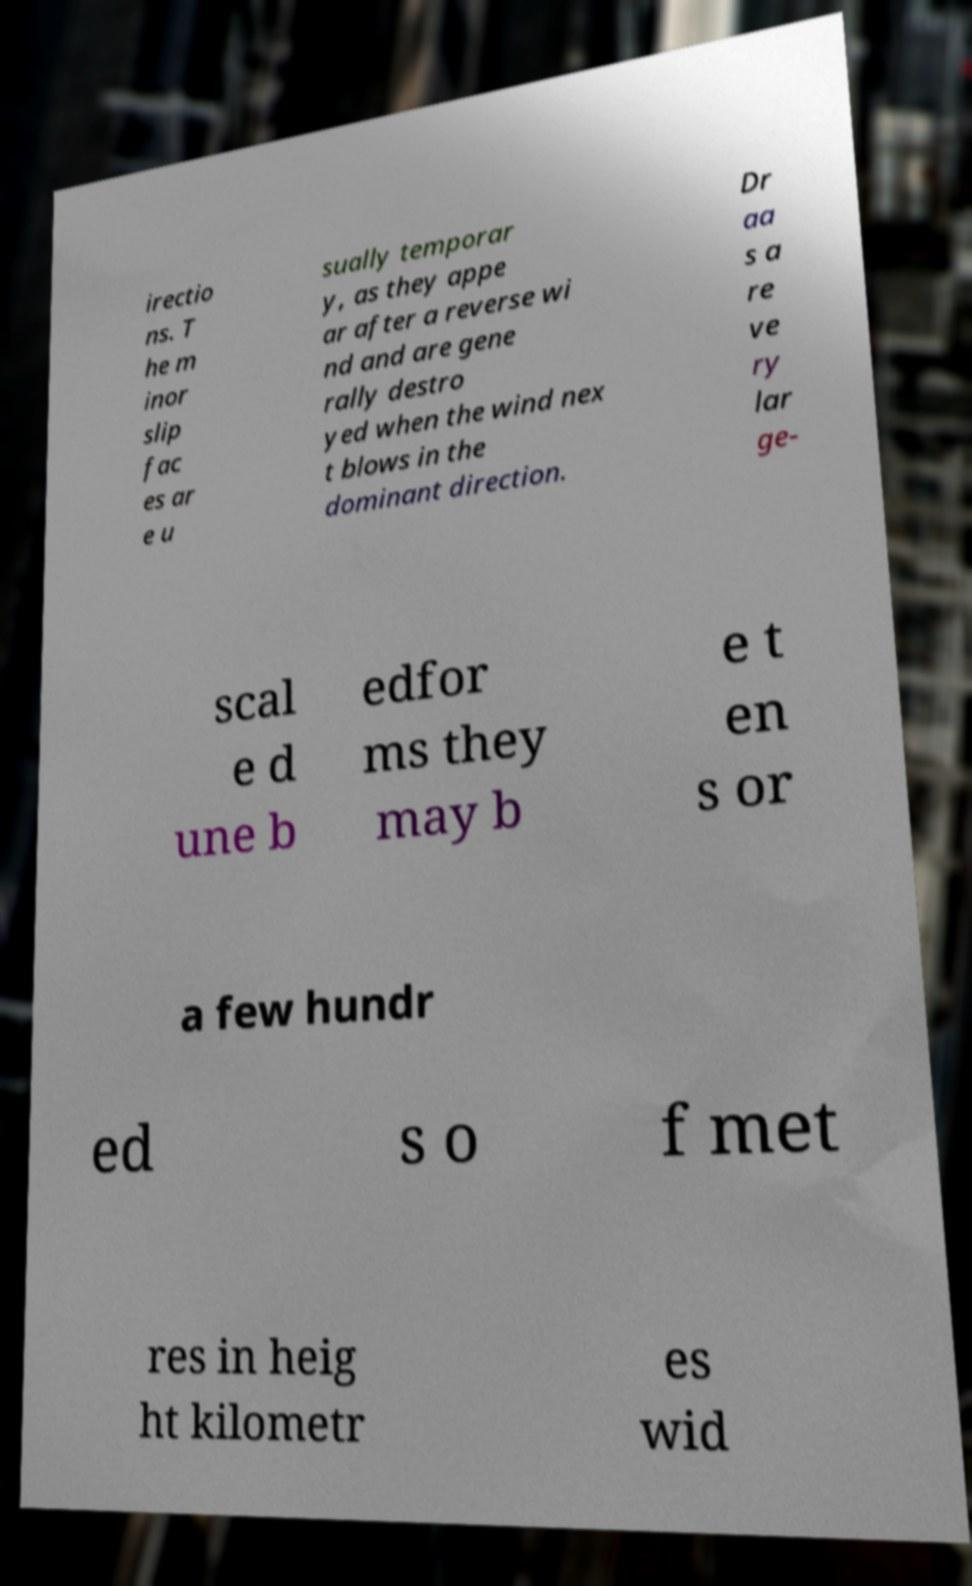For documentation purposes, I need the text within this image transcribed. Could you provide that? irectio ns. T he m inor slip fac es ar e u sually temporar y, as they appe ar after a reverse wi nd and are gene rally destro yed when the wind nex t blows in the dominant direction. Dr aa s a re ve ry lar ge- scal e d une b edfor ms they may b e t en s or a few hundr ed s o f met res in heig ht kilometr es wid 